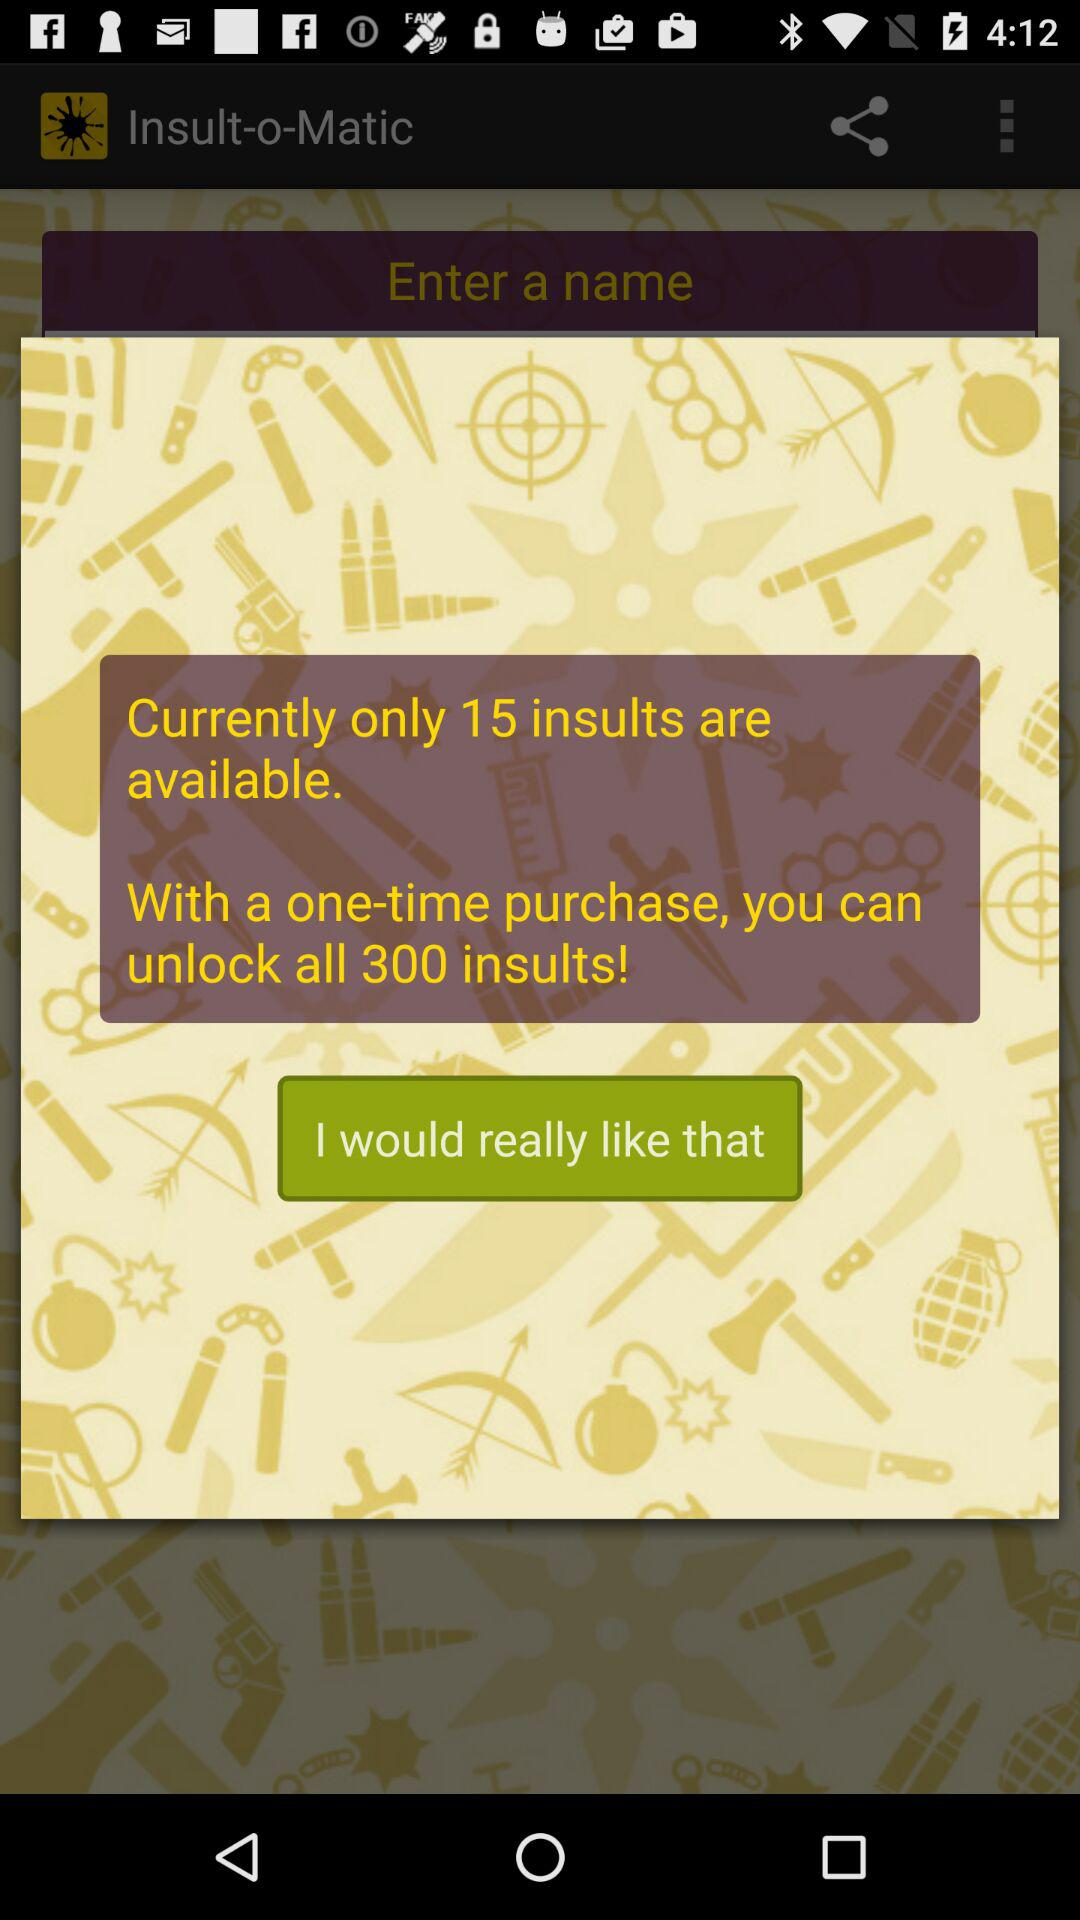How many more insults are available for purchase than are currently available?
Answer the question using a single word or phrase. 285 